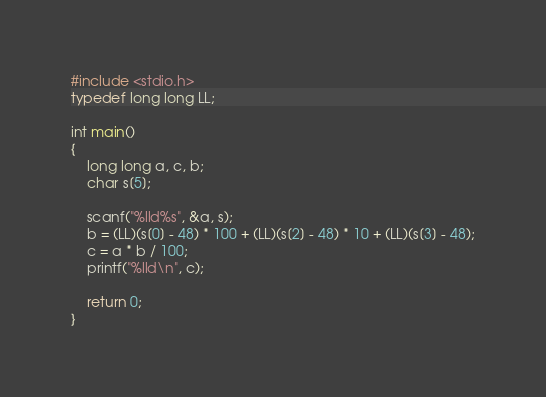Convert code to text. <code><loc_0><loc_0><loc_500><loc_500><_C_>#include <stdio.h>
typedef long long LL;

int main()
{	 
	long long a, c, b;
	char s[5];
	
	scanf("%lld%s", &a, s);
	b = (LL)(s[0] - 48) * 100 + (LL)(s[2] - 48) * 10 + (LL)(s[3] - 48);
	c = a * b / 100;
	printf("%lld\n", c);
		
	return 0;
}</code> 